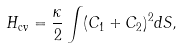Convert formula to latex. <formula><loc_0><loc_0><loc_500><loc_500>H _ { \text {cv} } = \frac { \kappa } { 2 } \int ( C _ { 1 } + C _ { 2 } ) ^ { 2 } d S ,</formula> 